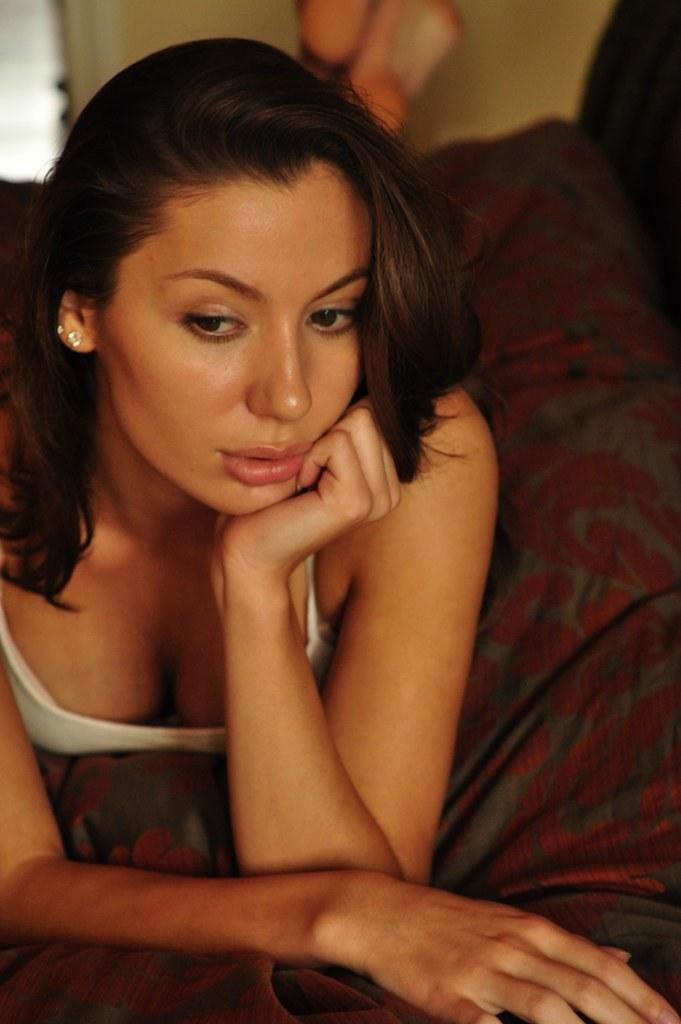What is the main subject of the image? There is a person in the image. What is the person doing in the image? The person is lying on an object. What type of sound can be heard coming from the playground in the image? There is no playground present in the image, so it's not possible to determine what, if any, sounds might be heard. 